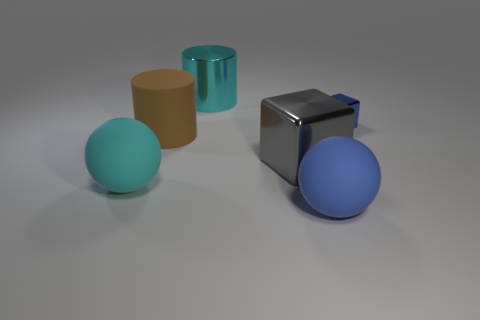Is there anything else that is the same size as the blue metal block?
Your answer should be compact. No. Is the number of small blue metallic blocks that are right of the small blue block less than the number of gray metallic things that are in front of the cyan ball?
Your answer should be compact. No. Is there anything else that has the same shape as the small metal thing?
Offer a very short reply. Yes. There is another object that is the same shape as the brown matte thing; what is its color?
Keep it short and to the point. Cyan. Do the big blue rubber object and the metallic object that is right of the gray metal object have the same shape?
Offer a very short reply. No. What number of objects are either metal cubes behind the brown cylinder or blue things that are behind the large cyan rubber sphere?
Keep it short and to the point. 1. What material is the brown thing?
Give a very brief answer. Rubber. What number of other things are there of the same size as the blue matte object?
Offer a very short reply. 4. How big is the cyan object in front of the matte cylinder?
Your answer should be very brief. Large. There is a large ball that is behind the big matte sphere that is in front of the rubber ball that is on the left side of the brown rubber cylinder; what is it made of?
Provide a short and direct response. Rubber. 